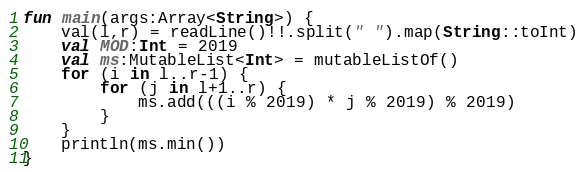<code> <loc_0><loc_0><loc_500><loc_500><_Kotlin_>fun main(args:Array<String>) {
    val(l,r) = readLine()!!.split(" ").map(String::toInt)
    val MOD:Int = 2019
    val ms:MutableList<Int> = mutableListOf()
    for (i in l..r-1) {
        for (j in l+1..r) {
            ms.add(((i % 2019) * j % 2019) % 2019)
        }
    }
    println(ms.min())
}
</code> 